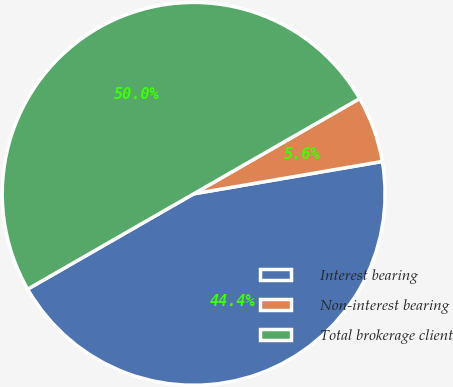<chart> <loc_0><loc_0><loc_500><loc_500><pie_chart><fcel>Interest bearing<fcel>Non-interest bearing<fcel>Total brokerage client<nl><fcel>44.41%<fcel>5.59%<fcel>50.0%<nl></chart> 